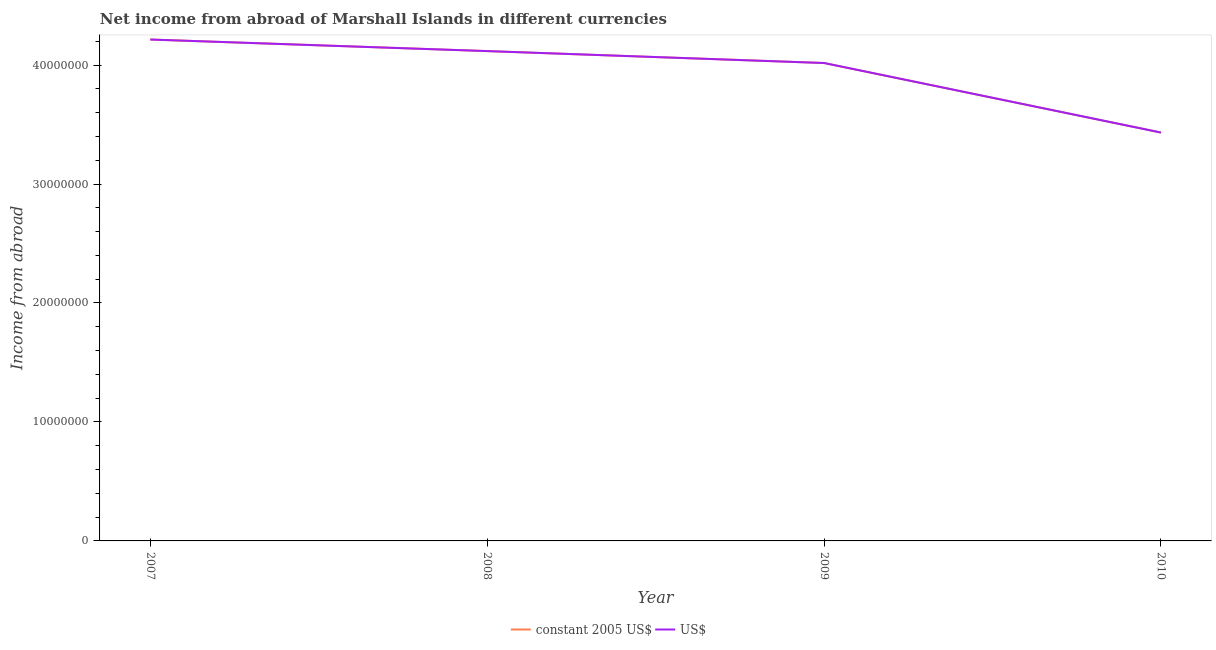How many different coloured lines are there?
Make the answer very short. 2. Does the line corresponding to income from abroad in us$ intersect with the line corresponding to income from abroad in constant 2005 us$?
Provide a succinct answer. Yes. Is the number of lines equal to the number of legend labels?
Your answer should be compact. Yes. What is the income from abroad in us$ in 2008?
Your answer should be compact. 4.12e+07. Across all years, what is the maximum income from abroad in constant 2005 us$?
Make the answer very short. 4.21e+07. Across all years, what is the minimum income from abroad in us$?
Ensure brevity in your answer.  3.43e+07. What is the total income from abroad in us$ in the graph?
Provide a short and direct response. 1.58e+08. What is the difference between the income from abroad in constant 2005 us$ in 2007 and that in 2010?
Offer a very short reply. 7.82e+06. What is the difference between the income from abroad in us$ in 2008 and the income from abroad in constant 2005 us$ in 2007?
Make the answer very short. -9.72e+05. What is the average income from abroad in us$ per year?
Provide a short and direct response. 3.95e+07. What is the ratio of the income from abroad in constant 2005 us$ in 2007 to that in 2009?
Your answer should be compact. 1.05. What is the difference between the highest and the second highest income from abroad in us$?
Ensure brevity in your answer.  9.72e+05. What is the difference between the highest and the lowest income from abroad in us$?
Provide a short and direct response. 7.82e+06. In how many years, is the income from abroad in us$ greater than the average income from abroad in us$ taken over all years?
Keep it short and to the point. 3. Is the income from abroad in us$ strictly less than the income from abroad in constant 2005 us$ over the years?
Your response must be concise. No. How many lines are there?
Your answer should be very brief. 2. How many years are there in the graph?
Your answer should be compact. 4. Are the values on the major ticks of Y-axis written in scientific E-notation?
Your answer should be compact. No. Does the graph contain any zero values?
Provide a short and direct response. No. Does the graph contain grids?
Your answer should be very brief. No. What is the title of the graph?
Offer a terse response. Net income from abroad of Marshall Islands in different currencies. What is the label or title of the X-axis?
Ensure brevity in your answer.  Year. What is the label or title of the Y-axis?
Give a very brief answer. Income from abroad. What is the Income from abroad in constant 2005 US$ in 2007?
Your response must be concise. 4.21e+07. What is the Income from abroad in US$ in 2007?
Offer a very short reply. 4.21e+07. What is the Income from abroad in constant 2005 US$ in 2008?
Make the answer very short. 4.12e+07. What is the Income from abroad of US$ in 2008?
Keep it short and to the point. 4.12e+07. What is the Income from abroad in constant 2005 US$ in 2009?
Your answer should be compact. 4.02e+07. What is the Income from abroad of US$ in 2009?
Give a very brief answer. 4.02e+07. What is the Income from abroad of constant 2005 US$ in 2010?
Give a very brief answer. 3.43e+07. What is the Income from abroad in US$ in 2010?
Make the answer very short. 3.43e+07. Across all years, what is the maximum Income from abroad in constant 2005 US$?
Offer a terse response. 4.21e+07. Across all years, what is the maximum Income from abroad in US$?
Offer a very short reply. 4.21e+07. Across all years, what is the minimum Income from abroad in constant 2005 US$?
Offer a terse response. 3.43e+07. Across all years, what is the minimum Income from abroad in US$?
Keep it short and to the point. 3.43e+07. What is the total Income from abroad in constant 2005 US$ in the graph?
Ensure brevity in your answer.  1.58e+08. What is the total Income from abroad of US$ in the graph?
Offer a very short reply. 1.58e+08. What is the difference between the Income from abroad of constant 2005 US$ in 2007 and that in 2008?
Provide a short and direct response. 9.72e+05. What is the difference between the Income from abroad of US$ in 2007 and that in 2008?
Provide a succinct answer. 9.72e+05. What is the difference between the Income from abroad of constant 2005 US$ in 2007 and that in 2009?
Your answer should be very brief. 1.97e+06. What is the difference between the Income from abroad in US$ in 2007 and that in 2009?
Your answer should be very brief. 1.97e+06. What is the difference between the Income from abroad in constant 2005 US$ in 2007 and that in 2010?
Offer a very short reply. 7.82e+06. What is the difference between the Income from abroad in US$ in 2007 and that in 2010?
Offer a terse response. 7.82e+06. What is the difference between the Income from abroad of constant 2005 US$ in 2008 and that in 2009?
Make the answer very short. 1.00e+06. What is the difference between the Income from abroad of US$ in 2008 and that in 2009?
Make the answer very short. 1.00e+06. What is the difference between the Income from abroad in constant 2005 US$ in 2008 and that in 2010?
Your answer should be compact. 6.85e+06. What is the difference between the Income from abroad in US$ in 2008 and that in 2010?
Offer a terse response. 6.85e+06. What is the difference between the Income from abroad in constant 2005 US$ in 2009 and that in 2010?
Offer a terse response. 5.84e+06. What is the difference between the Income from abroad of US$ in 2009 and that in 2010?
Give a very brief answer. 5.84e+06. What is the difference between the Income from abroad of constant 2005 US$ in 2007 and the Income from abroad of US$ in 2008?
Your response must be concise. 9.72e+05. What is the difference between the Income from abroad of constant 2005 US$ in 2007 and the Income from abroad of US$ in 2009?
Your answer should be compact. 1.97e+06. What is the difference between the Income from abroad in constant 2005 US$ in 2007 and the Income from abroad in US$ in 2010?
Offer a very short reply. 7.82e+06. What is the difference between the Income from abroad in constant 2005 US$ in 2008 and the Income from abroad in US$ in 2009?
Keep it short and to the point. 1.00e+06. What is the difference between the Income from abroad of constant 2005 US$ in 2008 and the Income from abroad of US$ in 2010?
Your answer should be compact. 6.85e+06. What is the difference between the Income from abroad of constant 2005 US$ in 2009 and the Income from abroad of US$ in 2010?
Provide a succinct answer. 5.84e+06. What is the average Income from abroad in constant 2005 US$ per year?
Your response must be concise. 3.95e+07. What is the average Income from abroad in US$ per year?
Ensure brevity in your answer.  3.95e+07. In the year 2007, what is the difference between the Income from abroad in constant 2005 US$ and Income from abroad in US$?
Your answer should be compact. 0. In the year 2008, what is the difference between the Income from abroad in constant 2005 US$ and Income from abroad in US$?
Your answer should be compact. 0. What is the ratio of the Income from abroad of constant 2005 US$ in 2007 to that in 2008?
Offer a terse response. 1.02. What is the ratio of the Income from abroad of US$ in 2007 to that in 2008?
Provide a short and direct response. 1.02. What is the ratio of the Income from abroad of constant 2005 US$ in 2007 to that in 2009?
Give a very brief answer. 1.05. What is the ratio of the Income from abroad of US$ in 2007 to that in 2009?
Provide a succinct answer. 1.05. What is the ratio of the Income from abroad in constant 2005 US$ in 2007 to that in 2010?
Ensure brevity in your answer.  1.23. What is the ratio of the Income from abroad of US$ in 2007 to that in 2010?
Your answer should be very brief. 1.23. What is the ratio of the Income from abroad in constant 2005 US$ in 2008 to that in 2009?
Provide a short and direct response. 1.02. What is the ratio of the Income from abroad in US$ in 2008 to that in 2009?
Offer a very short reply. 1.02. What is the ratio of the Income from abroad in constant 2005 US$ in 2008 to that in 2010?
Make the answer very short. 1.2. What is the ratio of the Income from abroad in US$ in 2008 to that in 2010?
Keep it short and to the point. 1.2. What is the ratio of the Income from abroad of constant 2005 US$ in 2009 to that in 2010?
Keep it short and to the point. 1.17. What is the ratio of the Income from abroad in US$ in 2009 to that in 2010?
Your answer should be very brief. 1.17. What is the difference between the highest and the second highest Income from abroad in constant 2005 US$?
Make the answer very short. 9.72e+05. What is the difference between the highest and the second highest Income from abroad of US$?
Keep it short and to the point. 9.72e+05. What is the difference between the highest and the lowest Income from abroad in constant 2005 US$?
Your response must be concise. 7.82e+06. What is the difference between the highest and the lowest Income from abroad of US$?
Offer a terse response. 7.82e+06. 